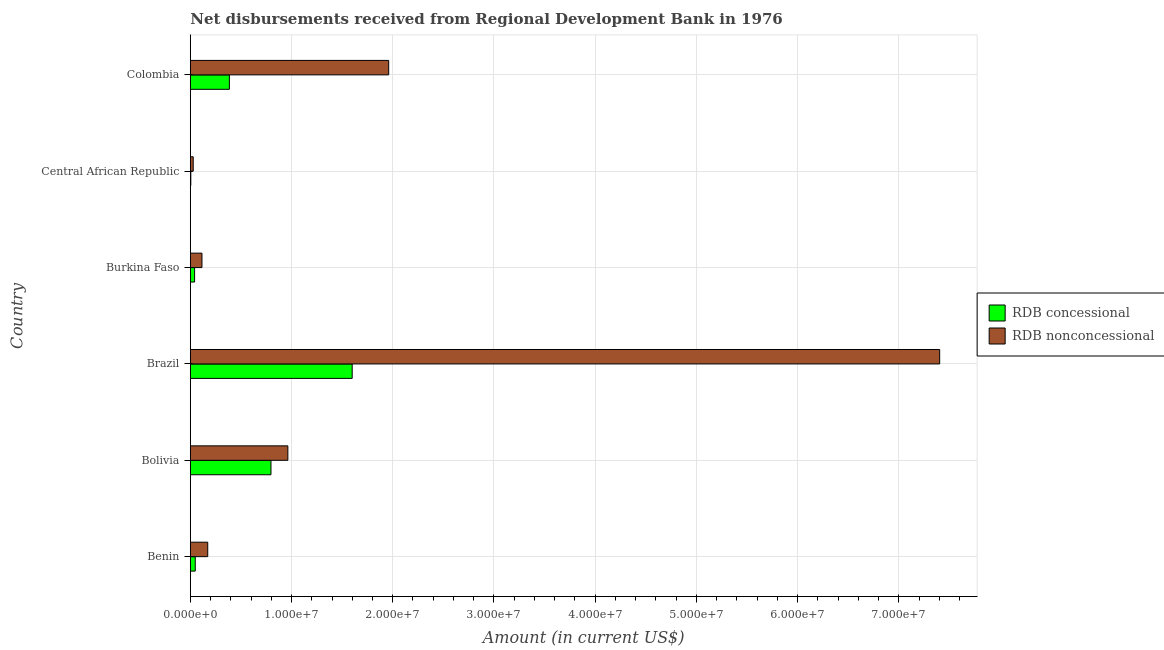Are the number of bars on each tick of the Y-axis equal?
Offer a very short reply. Yes. How many bars are there on the 3rd tick from the top?
Offer a terse response. 2. How many bars are there on the 3rd tick from the bottom?
Your response must be concise. 2. What is the label of the 5th group of bars from the top?
Keep it short and to the point. Bolivia. What is the net concessional disbursements from rdb in Brazil?
Keep it short and to the point. 1.60e+07. Across all countries, what is the maximum net non concessional disbursements from rdb?
Your answer should be very brief. 7.40e+07. Across all countries, what is the minimum net concessional disbursements from rdb?
Your response must be concise. 5.10e+04. In which country was the net non concessional disbursements from rdb minimum?
Offer a terse response. Central African Republic. What is the total net concessional disbursements from rdb in the graph?
Offer a very short reply. 2.88e+07. What is the difference between the net concessional disbursements from rdb in Burkina Faso and that in Central African Republic?
Provide a succinct answer. 3.74e+05. What is the difference between the net non concessional disbursements from rdb in Central African Republic and the net concessional disbursements from rdb in Bolivia?
Give a very brief answer. -7.68e+06. What is the average net concessional disbursements from rdb per country?
Offer a terse response. 4.80e+06. What is the difference between the net concessional disbursements from rdb and net non concessional disbursements from rdb in Benin?
Your answer should be compact. -1.23e+06. In how many countries, is the net non concessional disbursements from rdb greater than 28000000 US$?
Your answer should be compact. 1. What is the ratio of the net non concessional disbursements from rdb in Bolivia to that in Burkina Faso?
Ensure brevity in your answer.  8.35. Is the difference between the net concessional disbursements from rdb in Benin and Colombia greater than the difference between the net non concessional disbursements from rdb in Benin and Colombia?
Offer a very short reply. Yes. What is the difference between the highest and the second highest net concessional disbursements from rdb?
Provide a succinct answer. 8.02e+06. What is the difference between the highest and the lowest net non concessional disbursements from rdb?
Make the answer very short. 7.37e+07. In how many countries, is the net non concessional disbursements from rdb greater than the average net non concessional disbursements from rdb taken over all countries?
Your answer should be compact. 2. Is the sum of the net concessional disbursements from rdb in Brazil and Central African Republic greater than the maximum net non concessional disbursements from rdb across all countries?
Ensure brevity in your answer.  No. What does the 1st bar from the top in Central African Republic represents?
Ensure brevity in your answer.  RDB nonconcessional. What does the 1st bar from the bottom in Benin represents?
Keep it short and to the point. RDB concessional. Are all the bars in the graph horizontal?
Keep it short and to the point. Yes. How many countries are there in the graph?
Your answer should be very brief. 6. Are the values on the major ticks of X-axis written in scientific E-notation?
Provide a succinct answer. Yes. Where does the legend appear in the graph?
Your answer should be compact. Center right. What is the title of the graph?
Ensure brevity in your answer.  Net disbursements received from Regional Development Bank in 1976. What is the Amount (in current US$) of RDB concessional in Benin?
Make the answer very short. 4.91e+05. What is the Amount (in current US$) in RDB nonconcessional in Benin?
Your answer should be very brief. 1.72e+06. What is the Amount (in current US$) in RDB concessional in Bolivia?
Your answer should be very brief. 7.97e+06. What is the Amount (in current US$) in RDB nonconcessional in Bolivia?
Keep it short and to the point. 9.64e+06. What is the Amount (in current US$) in RDB concessional in Brazil?
Your response must be concise. 1.60e+07. What is the Amount (in current US$) of RDB nonconcessional in Brazil?
Provide a short and direct response. 7.40e+07. What is the Amount (in current US$) in RDB concessional in Burkina Faso?
Provide a succinct answer. 4.25e+05. What is the Amount (in current US$) in RDB nonconcessional in Burkina Faso?
Provide a short and direct response. 1.15e+06. What is the Amount (in current US$) in RDB concessional in Central African Republic?
Make the answer very short. 5.10e+04. What is the Amount (in current US$) in RDB nonconcessional in Central African Republic?
Offer a very short reply. 2.89e+05. What is the Amount (in current US$) of RDB concessional in Colombia?
Your response must be concise. 3.86e+06. What is the Amount (in current US$) of RDB nonconcessional in Colombia?
Your answer should be very brief. 1.96e+07. Across all countries, what is the maximum Amount (in current US$) in RDB concessional?
Provide a succinct answer. 1.60e+07. Across all countries, what is the maximum Amount (in current US$) in RDB nonconcessional?
Your answer should be compact. 7.40e+07. Across all countries, what is the minimum Amount (in current US$) in RDB concessional?
Keep it short and to the point. 5.10e+04. Across all countries, what is the minimum Amount (in current US$) of RDB nonconcessional?
Give a very brief answer. 2.89e+05. What is the total Amount (in current US$) in RDB concessional in the graph?
Make the answer very short. 2.88e+07. What is the total Amount (in current US$) of RDB nonconcessional in the graph?
Make the answer very short. 1.06e+08. What is the difference between the Amount (in current US$) in RDB concessional in Benin and that in Bolivia?
Give a very brief answer. -7.48e+06. What is the difference between the Amount (in current US$) in RDB nonconcessional in Benin and that in Bolivia?
Make the answer very short. -7.92e+06. What is the difference between the Amount (in current US$) in RDB concessional in Benin and that in Brazil?
Give a very brief answer. -1.55e+07. What is the difference between the Amount (in current US$) of RDB nonconcessional in Benin and that in Brazil?
Provide a succinct answer. -7.23e+07. What is the difference between the Amount (in current US$) of RDB concessional in Benin and that in Burkina Faso?
Ensure brevity in your answer.  6.60e+04. What is the difference between the Amount (in current US$) of RDB nonconcessional in Benin and that in Burkina Faso?
Offer a very short reply. 5.69e+05. What is the difference between the Amount (in current US$) of RDB concessional in Benin and that in Central African Republic?
Ensure brevity in your answer.  4.40e+05. What is the difference between the Amount (in current US$) in RDB nonconcessional in Benin and that in Central African Republic?
Provide a succinct answer. 1.43e+06. What is the difference between the Amount (in current US$) of RDB concessional in Benin and that in Colombia?
Provide a short and direct response. -3.37e+06. What is the difference between the Amount (in current US$) in RDB nonconcessional in Benin and that in Colombia?
Keep it short and to the point. -1.79e+07. What is the difference between the Amount (in current US$) in RDB concessional in Bolivia and that in Brazil?
Provide a succinct answer. -8.02e+06. What is the difference between the Amount (in current US$) in RDB nonconcessional in Bolivia and that in Brazil?
Keep it short and to the point. -6.44e+07. What is the difference between the Amount (in current US$) in RDB concessional in Bolivia and that in Burkina Faso?
Provide a succinct answer. 7.54e+06. What is the difference between the Amount (in current US$) of RDB nonconcessional in Bolivia and that in Burkina Faso?
Provide a short and direct response. 8.48e+06. What is the difference between the Amount (in current US$) in RDB concessional in Bolivia and that in Central African Republic?
Keep it short and to the point. 7.92e+06. What is the difference between the Amount (in current US$) of RDB nonconcessional in Bolivia and that in Central African Republic?
Offer a very short reply. 9.35e+06. What is the difference between the Amount (in current US$) in RDB concessional in Bolivia and that in Colombia?
Your response must be concise. 4.11e+06. What is the difference between the Amount (in current US$) of RDB nonconcessional in Bolivia and that in Colombia?
Provide a short and direct response. -9.96e+06. What is the difference between the Amount (in current US$) of RDB concessional in Brazil and that in Burkina Faso?
Your answer should be compact. 1.56e+07. What is the difference between the Amount (in current US$) of RDB nonconcessional in Brazil and that in Burkina Faso?
Your answer should be very brief. 7.29e+07. What is the difference between the Amount (in current US$) of RDB concessional in Brazil and that in Central African Republic?
Offer a terse response. 1.59e+07. What is the difference between the Amount (in current US$) of RDB nonconcessional in Brazil and that in Central African Republic?
Provide a succinct answer. 7.37e+07. What is the difference between the Amount (in current US$) of RDB concessional in Brazil and that in Colombia?
Offer a very short reply. 1.21e+07. What is the difference between the Amount (in current US$) of RDB nonconcessional in Brazil and that in Colombia?
Make the answer very short. 5.44e+07. What is the difference between the Amount (in current US$) in RDB concessional in Burkina Faso and that in Central African Republic?
Offer a very short reply. 3.74e+05. What is the difference between the Amount (in current US$) of RDB nonconcessional in Burkina Faso and that in Central African Republic?
Your answer should be very brief. 8.65e+05. What is the difference between the Amount (in current US$) of RDB concessional in Burkina Faso and that in Colombia?
Give a very brief answer. -3.44e+06. What is the difference between the Amount (in current US$) of RDB nonconcessional in Burkina Faso and that in Colombia?
Provide a short and direct response. -1.84e+07. What is the difference between the Amount (in current US$) of RDB concessional in Central African Republic and that in Colombia?
Ensure brevity in your answer.  -3.81e+06. What is the difference between the Amount (in current US$) in RDB nonconcessional in Central African Republic and that in Colombia?
Offer a very short reply. -1.93e+07. What is the difference between the Amount (in current US$) of RDB concessional in Benin and the Amount (in current US$) of RDB nonconcessional in Bolivia?
Your answer should be very brief. -9.15e+06. What is the difference between the Amount (in current US$) of RDB concessional in Benin and the Amount (in current US$) of RDB nonconcessional in Brazil?
Provide a succinct answer. -7.35e+07. What is the difference between the Amount (in current US$) in RDB concessional in Benin and the Amount (in current US$) in RDB nonconcessional in Burkina Faso?
Give a very brief answer. -6.63e+05. What is the difference between the Amount (in current US$) of RDB concessional in Benin and the Amount (in current US$) of RDB nonconcessional in Central African Republic?
Your answer should be very brief. 2.02e+05. What is the difference between the Amount (in current US$) in RDB concessional in Benin and the Amount (in current US$) in RDB nonconcessional in Colombia?
Ensure brevity in your answer.  -1.91e+07. What is the difference between the Amount (in current US$) in RDB concessional in Bolivia and the Amount (in current US$) in RDB nonconcessional in Brazil?
Your answer should be compact. -6.61e+07. What is the difference between the Amount (in current US$) of RDB concessional in Bolivia and the Amount (in current US$) of RDB nonconcessional in Burkina Faso?
Make the answer very short. 6.82e+06. What is the difference between the Amount (in current US$) in RDB concessional in Bolivia and the Amount (in current US$) in RDB nonconcessional in Central African Republic?
Your answer should be very brief. 7.68e+06. What is the difference between the Amount (in current US$) of RDB concessional in Bolivia and the Amount (in current US$) of RDB nonconcessional in Colombia?
Your answer should be compact. -1.16e+07. What is the difference between the Amount (in current US$) of RDB concessional in Brazil and the Amount (in current US$) of RDB nonconcessional in Burkina Faso?
Keep it short and to the point. 1.48e+07. What is the difference between the Amount (in current US$) of RDB concessional in Brazil and the Amount (in current US$) of RDB nonconcessional in Central African Republic?
Offer a terse response. 1.57e+07. What is the difference between the Amount (in current US$) of RDB concessional in Brazil and the Amount (in current US$) of RDB nonconcessional in Colombia?
Offer a terse response. -3.61e+06. What is the difference between the Amount (in current US$) of RDB concessional in Burkina Faso and the Amount (in current US$) of RDB nonconcessional in Central African Republic?
Your answer should be compact. 1.36e+05. What is the difference between the Amount (in current US$) in RDB concessional in Burkina Faso and the Amount (in current US$) in RDB nonconcessional in Colombia?
Provide a short and direct response. -1.92e+07. What is the difference between the Amount (in current US$) of RDB concessional in Central African Republic and the Amount (in current US$) of RDB nonconcessional in Colombia?
Ensure brevity in your answer.  -1.95e+07. What is the average Amount (in current US$) in RDB concessional per country?
Keep it short and to the point. 4.80e+06. What is the average Amount (in current US$) in RDB nonconcessional per country?
Your response must be concise. 1.77e+07. What is the difference between the Amount (in current US$) of RDB concessional and Amount (in current US$) of RDB nonconcessional in Benin?
Ensure brevity in your answer.  -1.23e+06. What is the difference between the Amount (in current US$) in RDB concessional and Amount (in current US$) in RDB nonconcessional in Bolivia?
Offer a very short reply. -1.67e+06. What is the difference between the Amount (in current US$) in RDB concessional and Amount (in current US$) in RDB nonconcessional in Brazil?
Offer a very short reply. -5.80e+07. What is the difference between the Amount (in current US$) in RDB concessional and Amount (in current US$) in RDB nonconcessional in Burkina Faso?
Provide a short and direct response. -7.29e+05. What is the difference between the Amount (in current US$) of RDB concessional and Amount (in current US$) of RDB nonconcessional in Central African Republic?
Offer a very short reply. -2.38e+05. What is the difference between the Amount (in current US$) of RDB concessional and Amount (in current US$) of RDB nonconcessional in Colombia?
Ensure brevity in your answer.  -1.57e+07. What is the ratio of the Amount (in current US$) in RDB concessional in Benin to that in Bolivia?
Offer a terse response. 0.06. What is the ratio of the Amount (in current US$) in RDB nonconcessional in Benin to that in Bolivia?
Your answer should be compact. 0.18. What is the ratio of the Amount (in current US$) of RDB concessional in Benin to that in Brazil?
Keep it short and to the point. 0.03. What is the ratio of the Amount (in current US$) of RDB nonconcessional in Benin to that in Brazil?
Provide a succinct answer. 0.02. What is the ratio of the Amount (in current US$) in RDB concessional in Benin to that in Burkina Faso?
Offer a very short reply. 1.16. What is the ratio of the Amount (in current US$) of RDB nonconcessional in Benin to that in Burkina Faso?
Your response must be concise. 1.49. What is the ratio of the Amount (in current US$) of RDB concessional in Benin to that in Central African Republic?
Give a very brief answer. 9.63. What is the ratio of the Amount (in current US$) in RDB nonconcessional in Benin to that in Central African Republic?
Your answer should be very brief. 5.96. What is the ratio of the Amount (in current US$) in RDB concessional in Benin to that in Colombia?
Your answer should be very brief. 0.13. What is the ratio of the Amount (in current US$) in RDB nonconcessional in Benin to that in Colombia?
Your answer should be compact. 0.09. What is the ratio of the Amount (in current US$) of RDB concessional in Bolivia to that in Brazil?
Your response must be concise. 0.5. What is the ratio of the Amount (in current US$) in RDB nonconcessional in Bolivia to that in Brazil?
Make the answer very short. 0.13. What is the ratio of the Amount (in current US$) in RDB concessional in Bolivia to that in Burkina Faso?
Your answer should be compact. 18.75. What is the ratio of the Amount (in current US$) of RDB nonconcessional in Bolivia to that in Burkina Faso?
Offer a terse response. 8.35. What is the ratio of the Amount (in current US$) of RDB concessional in Bolivia to that in Central African Republic?
Ensure brevity in your answer.  156.27. What is the ratio of the Amount (in current US$) of RDB nonconcessional in Bolivia to that in Central African Republic?
Offer a very short reply. 33.35. What is the ratio of the Amount (in current US$) in RDB concessional in Bolivia to that in Colombia?
Provide a succinct answer. 2.06. What is the ratio of the Amount (in current US$) in RDB nonconcessional in Bolivia to that in Colombia?
Keep it short and to the point. 0.49. What is the ratio of the Amount (in current US$) in RDB concessional in Brazil to that in Burkina Faso?
Provide a succinct answer. 37.63. What is the ratio of the Amount (in current US$) in RDB nonconcessional in Brazil to that in Burkina Faso?
Offer a terse response. 64.15. What is the ratio of the Amount (in current US$) in RDB concessional in Brazil to that in Central African Republic?
Make the answer very short. 313.59. What is the ratio of the Amount (in current US$) in RDB nonconcessional in Brazil to that in Central African Republic?
Make the answer very short. 256.17. What is the ratio of the Amount (in current US$) in RDB concessional in Brazil to that in Colombia?
Keep it short and to the point. 4.14. What is the ratio of the Amount (in current US$) in RDB nonconcessional in Brazil to that in Colombia?
Your response must be concise. 3.78. What is the ratio of the Amount (in current US$) in RDB concessional in Burkina Faso to that in Central African Republic?
Give a very brief answer. 8.33. What is the ratio of the Amount (in current US$) of RDB nonconcessional in Burkina Faso to that in Central African Republic?
Make the answer very short. 3.99. What is the ratio of the Amount (in current US$) of RDB concessional in Burkina Faso to that in Colombia?
Give a very brief answer. 0.11. What is the ratio of the Amount (in current US$) in RDB nonconcessional in Burkina Faso to that in Colombia?
Your answer should be compact. 0.06. What is the ratio of the Amount (in current US$) in RDB concessional in Central African Republic to that in Colombia?
Offer a very short reply. 0.01. What is the ratio of the Amount (in current US$) of RDB nonconcessional in Central African Republic to that in Colombia?
Provide a short and direct response. 0.01. What is the difference between the highest and the second highest Amount (in current US$) of RDB concessional?
Your answer should be very brief. 8.02e+06. What is the difference between the highest and the second highest Amount (in current US$) in RDB nonconcessional?
Keep it short and to the point. 5.44e+07. What is the difference between the highest and the lowest Amount (in current US$) in RDB concessional?
Ensure brevity in your answer.  1.59e+07. What is the difference between the highest and the lowest Amount (in current US$) of RDB nonconcessional?
Make the answer very short. 7.37e+07. 